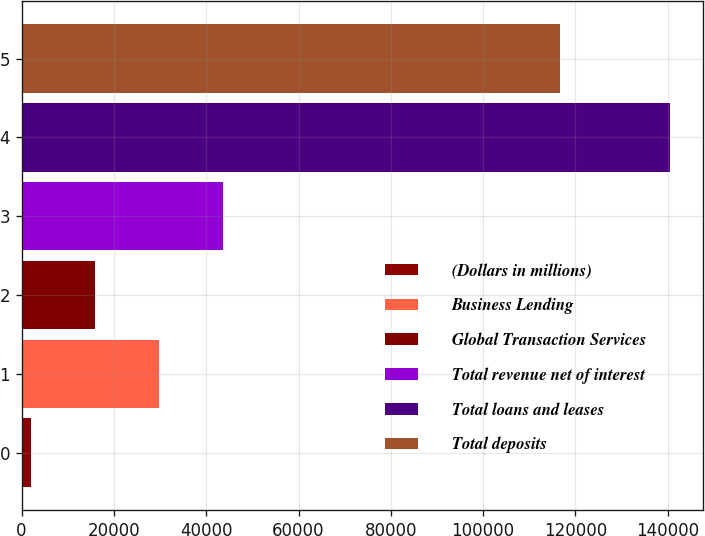Convert chart to OTSL. <chart><loc_0><loc_0><loc_500><loc_500><bar_chart><fcel>(Dollars in millions)<fcel>Business Lending<fcel>Global Transaction Services<fcel>Total revenue net of interest<fcel>Total loans and leases<fcel>Total deposits<nl><fcel>2014<fcel>29719<fcel>15866.5<fcel>43571.5<fcel>140539<fcel>116570<nl></chart> 